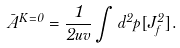Convert formula to latex. <formula><loc_0><loc_0><loc_500><loc_500>\bar { A } ^ { K = 0 } = \frac { 1 } { 2 u v } \int d ^ { 2 } p [ J ^ { 2 } _ { f } ] .</formula> 